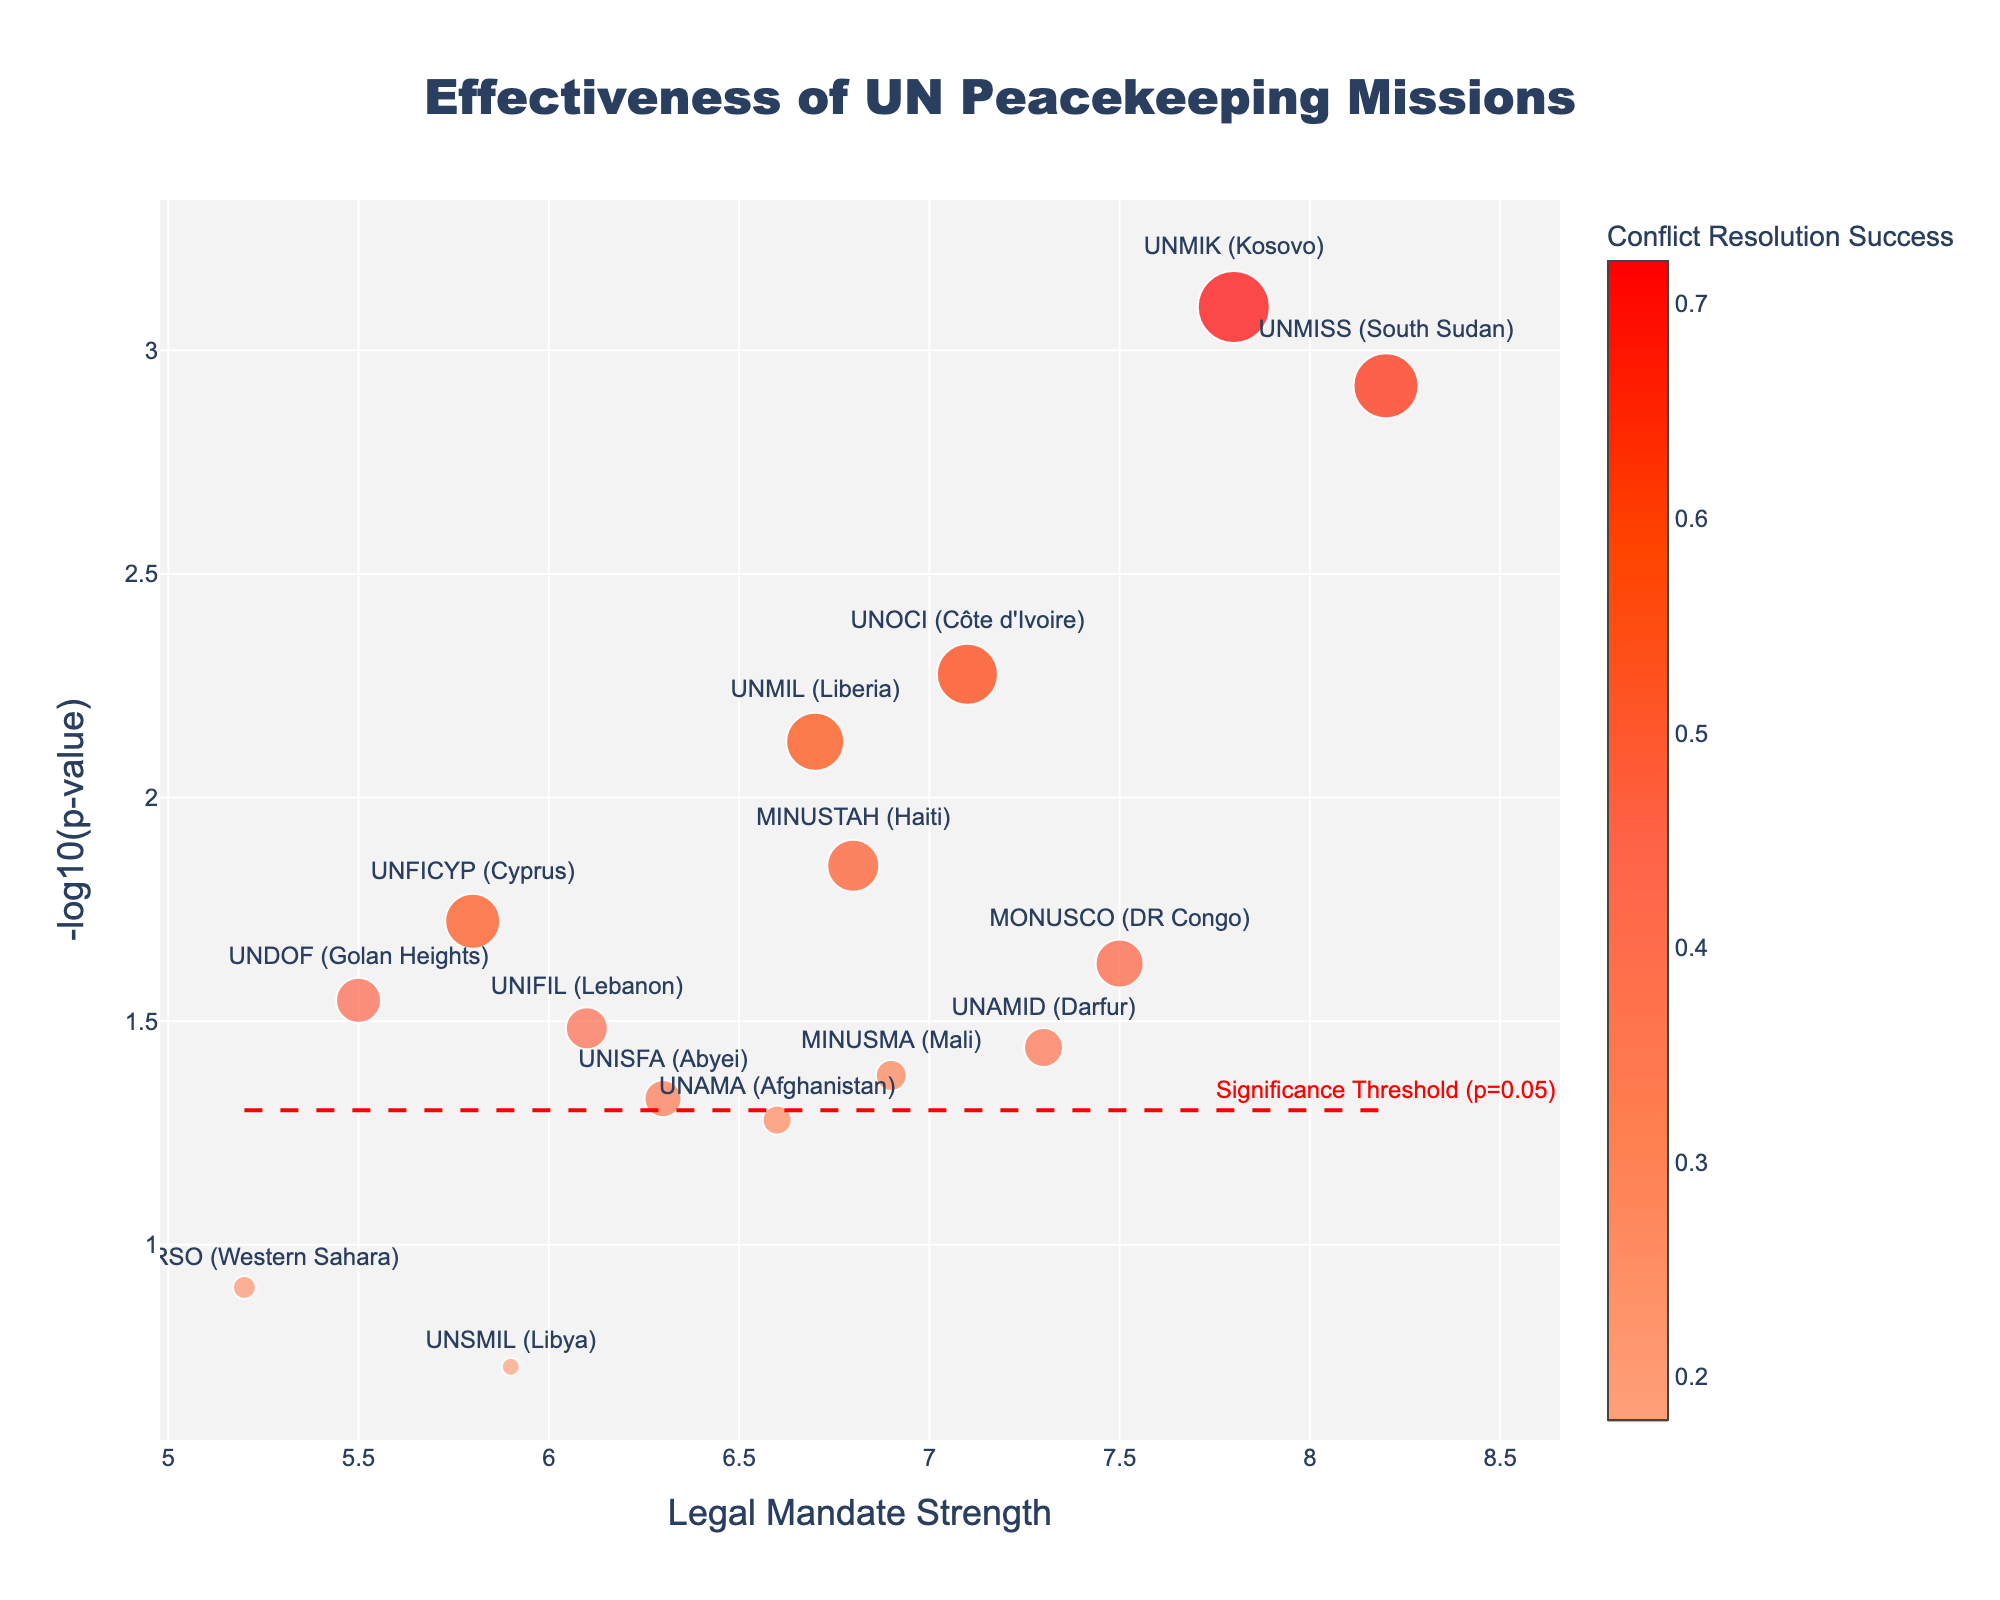How many missions are above the significance threshold line in the plot? The significance threshold is at -log10(p-value) = 1.3, which corresponds to p=0.05. Count the number of data points above this line. There are 12 points with a -log10(p-value) > 1.3.
Answer: 12 Which mission has the highest legal mandate strength? Look at the x-axis values and identify the mission with the highest legal mandate strength. This is UNMISS (South Sudan) with a legal mandate strength of 8.2.
Answer: UNMISS (South Sudan) Which mission has the lowest conflict resolution success rate? Compare the size of the markers, which represent conflict resolution success rate. The smallest marker corresponds to UNSMIL (Libya) with a success rate of 0.18.
Answer: UNSMIL (Libya) What is the legal mandate strength of the mission with the highest conflict resolution success rate? Look for the largest marker (indicating the highest conflict resolution success) and read the corresponding x-axis value. The mission is UNMIK (Kosovo) with a mandate strength of 7.8.
Answer: 7.8 Are there any missions with a p-value greater than 0.1 (less significant)? -log10(0.1) is 1. Check if any data points are below this value. The missions are MINURSO (Western Sahara) and UNSMIL (Libya).
Answer: Yes Which mission has the highest -log10(p-value)? Identify the data point with the highest y-axis value. This point corresponds to UNMIK (Kosovo) with a value of about 3.10.
Answer: UNMIK (Kosovo) Among the missions with a legal mandate strength greater than 7, which one has the lowest conflict resolution success rate? Filter the points with x-axis values > 7 and compare the marker sizes within that group. MINUSMA (Mali) has the smallest marker in this subset.
Answer: MONUSCO (DR Congo) What is the ratio of the conflict resolution success rates between UNMIK (Kosovo) and UNMISS (South Sudan)? The success rates are 0.72 for UNMIK and 0.65 for UNMISS. The ratio is 0.72 / 0.65 = 1.11.
Answer: 1.11 What color represents the highest conflict resolution success? Consult the color bar to identify the color corresponding to the highest values. For the highest success rate, the color is bright red.
Answer: Bright red Which mission with a legal mandate strength of less than 6 has the highest conflict resolution success rate? Filter the points with x-axis values < 6 and compare the marker sizes. The mission is UNFICYP (Cyprus) with a success rate of 0.55.
Answer: UNFICYP (Cyprus) 